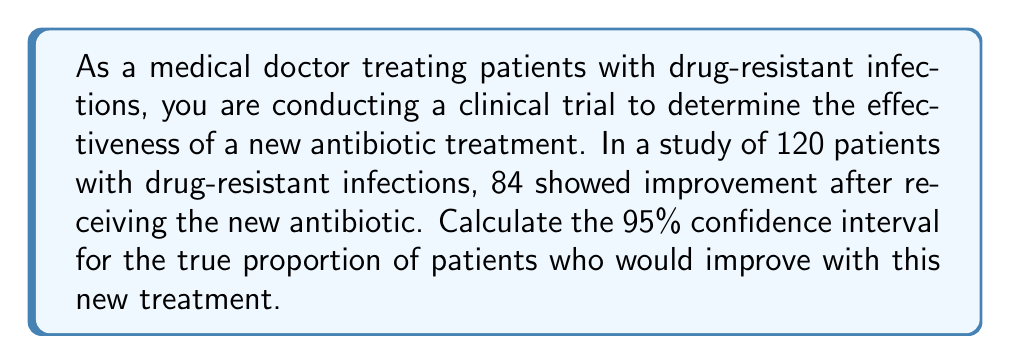Could you help me with this problem? To calculate the confidence interval for a proportion, we'll use the following steps:

1. Calculate the sample proportion:
   $\hat{p} = \frac{\text{number of successes}}{\text{total sample size}} = \frac{84}{120} = 0.7$

2. Calculate the standard error of the proportion:
   $SE = \sqrt{\frac{\hat{p}(1-\hat{p})}{n}} = \sqrt{\frac{0.7(1-0.7)}{120}} = \sqrt{\frac{0.21}{120}} \approx 0.0418$

3. For a 95% confidence interval, we use a z-score of 1.96 (from the standard normal distribution).

4. Calculate the margin of error:
   $ME = z \times SE = 1.96 \times 0.0418 \approx 0.0819$

5. Calculate the confidence interval:
   $CI = \hat{p} \pm ME$
   
   Lower bound: $0.7 - 0.0819 = 0.6181$
   Upper bound: $0.7 + 0.0819 = 0.7819$

Therefore, the 95% confidence interval is (0.6181, 0.7819) or (61.81%, 78.19%).

This means we can be 95% confident that the true proportion of patients who would improve with this new antibiotic treatment falls between 61.81% and 78.19%.
Answer: The 95% confidence interval for the true proportion of patients who would improve with the new antibiotic treatment is (0.6181, 0.7819) or (61.81%, 78.19%). 